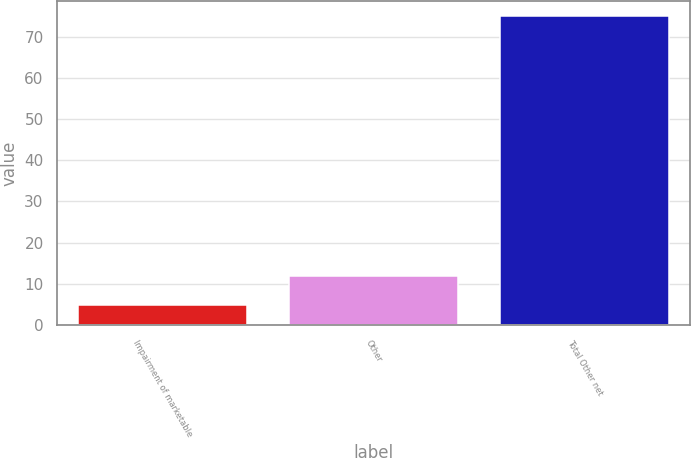<chart> <loc_0><loc_0><loc_500><loc_500><bar_chart><fcel>Impairment of marketable<fcel>Other<fcel>Total Other net<nl><fcel>5<fcel>12<fcel>75<nl></chart> 